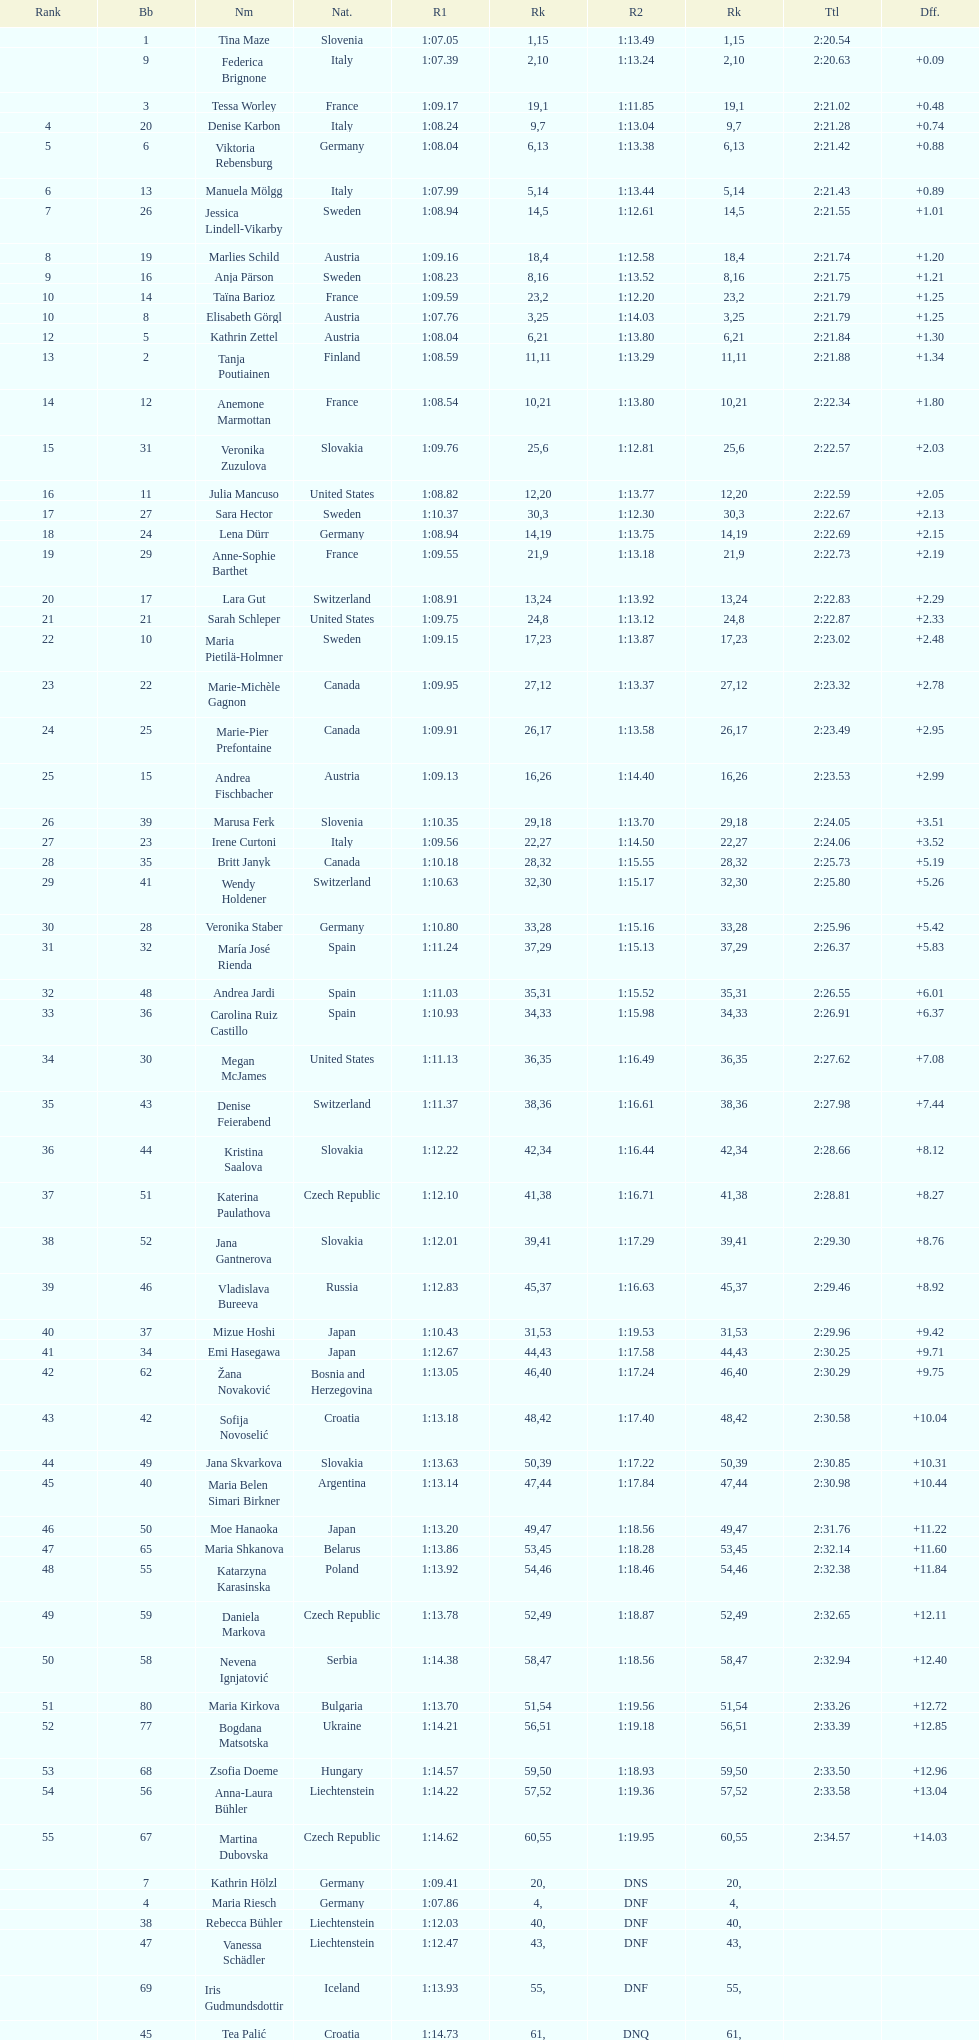Could you parse the entire table as a dict? {'header': ['Rank', 'Bb', 'Nm', 'Nat.', 'R1', 'Rk', 'R2', 'Rk', 'Ttl', 'Dff.'], 'rows': [['', '1', 'Tina Maze', 'Slovenia', '1:07.05', '1', '1:13.49', '15', '2:20.54', ''], ['', '9', 'Federica Brignone', 'Italy', '1:07.39', '2', '1:13.24', '10', '2:20.63', '+0.09'], ['', '3', 'Tessa Worley', 'France', '1:09.17', '19', '1:11.85', '1', '2:21.02', '+0.48'], ['4', '20', 'Denise Karbon', 'Italy', '1:08.24', '9', '1:13.04', '7', '2:21.28', '+0.74'], ['5', '6', 'Viktoria Rebensburg', 'Germany', '1:08.04', '6', '1:13.38', '13', '2:21.42', '+0.88'], ['6', '13', 'Manuela Mölgg', 'Italy', '1:07.99', '5', '1:13.44', '14', '2:21.43', '+0.89'], ['7', '26', 'Jessica Lindell-Vikarby', 'Sweden', '1:08.94', '14', '1:12.61', '5', '2:21.55', '+1.01'], ['8', '19', 'Marlies Schild', 'Austria', '1:09.16', '18', '1:12.58', '4', '2:21.74', '+1.20'], ['9', '16', 'Anja Pärson', 'Sweden', '1:08.23', '8', '1:13.52', '16', '2:21.75', '+1.21'], ['10', '14', 'Taïna Barioz', 'France', '1:09.59', '23', '1:12.20', '2', '2:21.79', '+1.25'], ['10', '8', 'Elisabeth Görgl', 'Austria', '1:07.76', '3', '1:14.03', '25', '2:21.79', '+1.25'], ['12', '5', 'Kathrin Zettel', 'Austria', '1:08.04', '6', '1:13.80', '21', '2:21.84', '+1.30'], ['13', '2', 'Tanja Poutiainen', 'Finland', '1:08.59', '11', '1:13.29', '11', '2:21.88', '+1.34'], ['14', '12', 'Anemone Marmottan', 'France', '1:08.54', '10', '1:13.80', '21', '2:22.34', '+1.80'], ['15', '31', 'Veronika Zuzulova', 'Slovakia', '1:09.76', '25', '1:12.81', '6', '2:22.57', '+2.03'], ['16', '11', 'Julia Mancuso', 'United States', '1:08.82', '12', '1:13.77', '20', '2:22.59', '+2.05'], ['17', '27', 'Sara Hector', 'Sweden', '1:10.37', '30', '1:12.30', '3', '2:22.67', '+2.13'], ['18', '24', 'Lena Dürr', 'Germany', '1:08.94', '14', '1:13.75', '19', '2:22.69', '+2.15'], ['19', '29', 'Anne-Sophie Barthet', 'France', '1:09.55', '21', '1:13.18', '9', '2:22.73', '+2.19'], ['20', '17', 'Lara Gut', 'Switzerland', '1:08.91', '13', '1:13.92', '24', '2:22.83', '+2.29'], ['21', '21', 'Sarah Schleper', 'United States', '1:09.75', '24', '1:13.12', '8', '2:22.87', '+2.33'], ['22', '10', 'Maria Pietilä-Holmner', 'Sweden', '1:09.15', '17', '1:13.87', '23', '2:23.02', '+2.48'], ['23', '22', 'Marie-Michèle Gagnon', 'Canada', '1:09.95', '27', '1:13.37', '12', '2:23.32', '+2.78'], ['24', '25', 'Marie-Pier Prefontaine', 'Canada', '1:09.91', '26', '1:13.58', '17', '2:23.49', '+2.95'], ['25', '15', 'Andrea Fischbacher', 'Austria', '1:09.13', '16', '1:14.40', '26', '2:23.53', '+2.99'], ['26', '39', 'Marusa Ferk', 'Slovenia', '1:10.35', '29', '1:13.70', '18', '2:24.05', '+3.51'], ['27', '23', 'Irene Curtoni', 'Italy', '1:09.56', '22', '1:14.50', '27', '2:24.06', '+3.52'], ['28', '35', 'Britt Janyk', 'Canada', '1:10.18', '28', '1:15.55', '32', '2:25.73', '+5.19'], ['29', '41', 'Wendy Holdener', 'Switzerland', '1:10.63', '32', '1:15.17', '30', '2:25.80', '+5.26'], ['30', '28', 'Veronika Staber', 'Germany', '1:10.80', '33', '1:15.16', '28', '2:25.96', '+5.42'], ['31', '32', 'María José Rienda', 'Spain', '1:11.24', '37', '1:15.13', '29', '2:26.37', '+5.83'], ['32', '48', 'Andrea Jardi', 'Spain', '1:11.03', '35', '1:15.52', '31', '2:26.55', '+6.01'], ['33', '36', 'Carolina Ruiz Castillo', 'Spain', '1:10.93', '34', '1:15.98', '33', '2:26.91', '+6.37'], ['34', '30', 'Megan McJames', 'United States', '1:11.13', '36', '1:16.49', '35', '2:27.62', '+7.08'], ['35', '43', 'Denise Feierabend', 'Switzerland', '1:11.37', '38', '1:16.61', '36', '2:27.98', '+7.44'], ['36', '44', 'Kristina Saalova', 'Slovakia', '1:12.22', '42', '1:16.44', '34', '2:28.66', '+8.12'], ['37', '51', 'Katerina Paulathova', 'Czech Republic', '1:12.10', '41', '1:16.71', '38', '2:28.81', '+8.27'], ['38', '52', 'Jana Gantnerova', 'Slovakia', '1:12.01', '39', '1:17.29', '41', '2:29.30', '+8.76'], ['39', '46', 'Vladislava Bureeva', 'Russia', '1:12.83', '45', '1:16.63', '37', '2:29.46', '+8.92'], ['40', '37', 'Mizue Hoshi', 'Japan', '1:10.43', '31', '1:19.53', '53', '2:29.96', '+9.42'], ['41', '34', 'Emi Hasegawa', 'Japan', '1:12.67', '44', '1:17.58', '43', '2:30.25', '+9.71'], ['42', '62', 'Žana Novaković', 'Bosnia and Herzegovina', '1:13.05', '46', '1:17.24', '40', '2:30.29', '+9.75'], ['43', '42', 'Sofija Novoselić', 'Croatia', '1:13.18', '48', '1:17.40', '42', '2:30.58', '+10.04'], ['44', '49', 'Jana Skvarkova', 'Slovakia', '1:13.63', '50', '1:17.22', '39', '2:30.85', '+10.31'], ['45', '40', 'Maria Belen Simari Birkner', 'Argentina', '1:13.14', '47', '1:17.84', '44', '2:30.98', '+10.44'], ['46', '50', 'Moe Hanaoka', 'Japan', '1:13.20', '49', '1:18.56', '47', '2:31.76', '+11.22'], ['47', '65', 'Maria Shkanova', 'Belarus', '1:13.86', '53', '1:18.28', '45', '2:32.14', '+11.60'], ['48', '55', 'Katarzyna Karasinska', 'Poland', '1:13.92', '54', '1:18.46', '46', '2:32.38', '+11.84'], ['49', '59', 'Daniela Markova', 'Czech Republic', '1:13.78', '52', '1:18.87', '49', '2:32.65', '+12.11'], ['50', '58', 'Nevena Ignjatović', 'Serbia', '1:14.38', '58', '1:18.56', '47', '2:32.94', '+12.40'], ['51', '80', 'Maria Kirkova', 'Bulgaria', '1:13.70', '51', '1:19.56', '54', '2:33.26', '+12.72'], ['52', '77', 'Bogdana Matsotska', 'Ukraine', '1:14.21', '56', '1:19.18', '51', '2:33.39', '+12.85'], ['53', '68', 'Zsofia Doeme', 'Hungary', '1:14.57', '59', '1:18.93', '50', '2:33.50', '+12.96'], ['54', '56', 'Anna-Laura Bühler', 'Liechtenstein', '1:14.22', '57', '1:19.36', '52', '2:33.58', '+13.04'], ['55', '67', 'Martina Dubovska', 'Czech Republic', '1:14.62', '60', '1:19.95', '55', '2:34.57', '+14.03'], ['', '7', 'Kathrin Hölzl', 'Germany', '1:09.41', '20', 'DNS', '', '', ''], ['', '4', 'Maria Riesch', 'Germany', '1:07.86', '4', 'DNF', '', '', ''], ['', '38', 'Rebecca Bühler', 'Liechtenstein', '1:12.03', '40', 'DNF', '', '', ''], ['', '47', 'Vanessa Schädler', 'Liechtenstein', '1:12.47', '43', 'DNF', '', '', ''], ['', '69', 'Iris Gudmundsdottir', 'Iceland', '1:13.93', '55', 'DNF', '', '', ''], ['', '45', 'Tea Palić', 'Croatia', '1:14.73', '61', 'DNQ', '', '', ''], ['', '74', 'Macarena Simari Birkner', 'Argentina', '1:15.18', '62', 'DNQ', '', '', ''], ['', '72', 'Lavinia Chrystal', 'Australia', '1:15.35', '63', 'DNQ', '', '', ''], ['', '81', 'Lelde Gasuna', 'Latvia', '1:15.37', '64', 'DNQ', '', '', ''], ['', '64', 'Aleksandra Klus', 'Poland', '1:15.41', '65', 'DNQ', '', '', ''], ['', '78', 'Nino Tsiklauri', 'Georgia', '1:15.54', '66', 'DNQ', '', '', ''], ['', '66', 'Sarah Jarvis', 'New Zealand', '1:15.94', '67', 'DNQ', '', '', ''], ['', '61', 'Anna Berecz', 'Hungary', '1:15.95', '68', 'DNQ', '', '', ''], ['', '83', 'Sandra-Elena Narea', 'Romania', '1:16.67', '69', 'DNQ', '', '', ''], ['', '85', 'Iulia Petruta Craciun', 'Romania', '1:16.80', '70', 'DNQ', '', '', ''], ['', '82', 'Isabel van Buynder', 'Belgium', '1:17.06', '71', 'DNQ', '', '', ''], ['', '97', 'Liene Fimbauere', 'Latvia', '1:17.83', '72', 'DNQ', '', '', ''], ['', '86', 'Kristina Krone', 'Puerto Rico', '1:17.93', '73', 'DNQ', '', '', ''], ['', '88', 'Nicole Valcareggi', 'Greece', '1:18.19', '74', 'DNQ', '', '', ''], ['', '100', 'Sophie Fjellvang-Sølling', 'Denmark', '1:18.37', '75', 'DNQ', '', '', ''], ['', '95', 'Ornella Oettl Reyes', 'Peru', '1:18.61', '76', 'DNQ', '', '', ''], ['', '73', 'Xia Lina', 'China', '1:19.12', '77', 'DNQ', '', '', ''], ['', '94', 'Kseniya Grigoreva', 'Uzbekistan', '1:19.16', '78', 'DNQ', '', '', ''], ['', '87', 'Tugba Dasdemir', 'Turkey', '1:21.50', '79', 'DNQ', '', '', ''], ['', '92', 'Malene Madsen', 'Denmark', '1:22.25', '80', 'DNQ', '', '', ''], ['', '84', 'Liu Yang', 'China', '1:22.80', '81', 'DNQ', '', '', ''], ['', '91', 'Yom Hirshfeld', 'Israel', '1:22.87', '82', 'DNQ', '', '', ''], ['', '75', 'Salome Bancora', 'Argentina', '1:23.08', '83', 'DNQ', '', '', ''], ['', '93', 'Ronnie Kiek-Gedalyahu', 'Israel', '1:23.38', '84', 'DNQ', '', '', ''], ['', '96', 'Chiara Marano', 'Brazil', '1:24.16', '85', 'DNQ', '', '', ''], ['', '113', 'Anne Libak Nielsen', 'Denmark', '1:25.08', '86', 'DNQ', '', '', ''], ['', '105', 'Donata Hellner', 'Hungary', '1:26.97', '87', 'DNQ', '', '', ''], ['', '102', 'Liu Yu', 'China', '1:27.03', '88', 'DNQ', '', '', ''], ['', '109', 'Lida Zvoznikova', 'Kyrgyzstan', '1:27.17', '89', 'DNQ', '', '', ''], ['', '103', 'Szelina Hellner', 'Hungary', '1:27.27', '90', 'DNQ', '', '', ''], ['', '114', 'Irina Volkova', 'Kyrgyzstan', '1:29.73', '91', 'DNQ', '', '', ''], ['', '106', 'Svetlana Baranova', 'Uzbekistan', '1:30.62', '92', 'DNQ', '', '', ''], ['', '108', 'Tatjana Baranova', 'Uzbekistan', '1:31.81', '93', 'DNQ', '', '', ''], ['', '110', 'Fatemeh Kiadarbandsari', 'Iran', '1:32.16', '94', 'DNQ', '', '', ''], ['', '107', 'Ziba Kalhor', 'Iran', '1:32.64', '95', 'DNQ', '', '', ''], ['', '104', 'Paraskevi Mavridou', 'Greece', '1:32.83', '96', 'DNQ', '', '', ''], ['', '99', 'Marjan Kalhor', 'Iran', '1:34.94', '97', 'DNQ', '', '', ''], ['', '112', 'Mitra Kalhor', 'Iran', '1:37.93', '98', 'DNQ', '', '', ''], ['', '115', 'Laura Bauer', 'South Africa', '1:42.19', '99', 'DNQ', '', '', ''], ['', '111', 'Sarah Ekmekejian', 'Lebanon', '1:42.22', '100', 'DNQ', '', '', ''], ['', '18', 'Fabienne Suter', 'Switzerland', 'DNS', '', '', '', '', ''], ['', '98', 'Maja Klepić', 'Bosnia and Herzegovina', 'DNS', '', '', '', '', ''], ['', '33', 'Agniezska Gasienica Daniel', 'Poland', 'DNF', '', '', '', '', ''], ['', '53', 'Karolina Chrapek', 'Poland', 'DNF', '', '', '', '', ''], ['', '54', 'Mireia Gutierrez', 'Andorra', 'DNF', '', '', '', '', ''], ['', '57', 'Brittany Phelan', 'Canada', 'DNF', '', '', '', '', ''], ['', '60', 'Tereza Kmochova', 'Czech Republic', 'DNF', '', '', '', '', ''], ['', '63', 'Michelle van Herwerden', 'Netherlands', 'DNF', '', '', '', '', ''], ['', '70', 'Maya Harrisson', 'Brazil', 'DNF', '', '', '', '', ''], ['', '71', 'Elizabeth Pilat', 'Australia', 'DNF', '', '', '', '', ''], ['', '76', 'Katrin Kristjansdottir', 'Iceland', 'DNF', '', '', '', '', ''], ['', '79', 'Julietta Quiroga', 'Argentina', 'DNF', '', '', '', '', ''], ['', '89', 'Evija Benhena', 'Latvia', 'DNF', '', '', '', '', ''], ['', '90', 'Qin Xiyue', 'China', 'DNF', '', '', '', '', ''], ['', '101', 'Sophia Ralli', 'Greece', 'DNF', '', '', '', '', ''], ['', '116', 'Siranush Maghakyan', 'Armenia', 'DNF', '', '', '', '', '']]} How long did it take tina maze to finish the race? 2:20.54. 